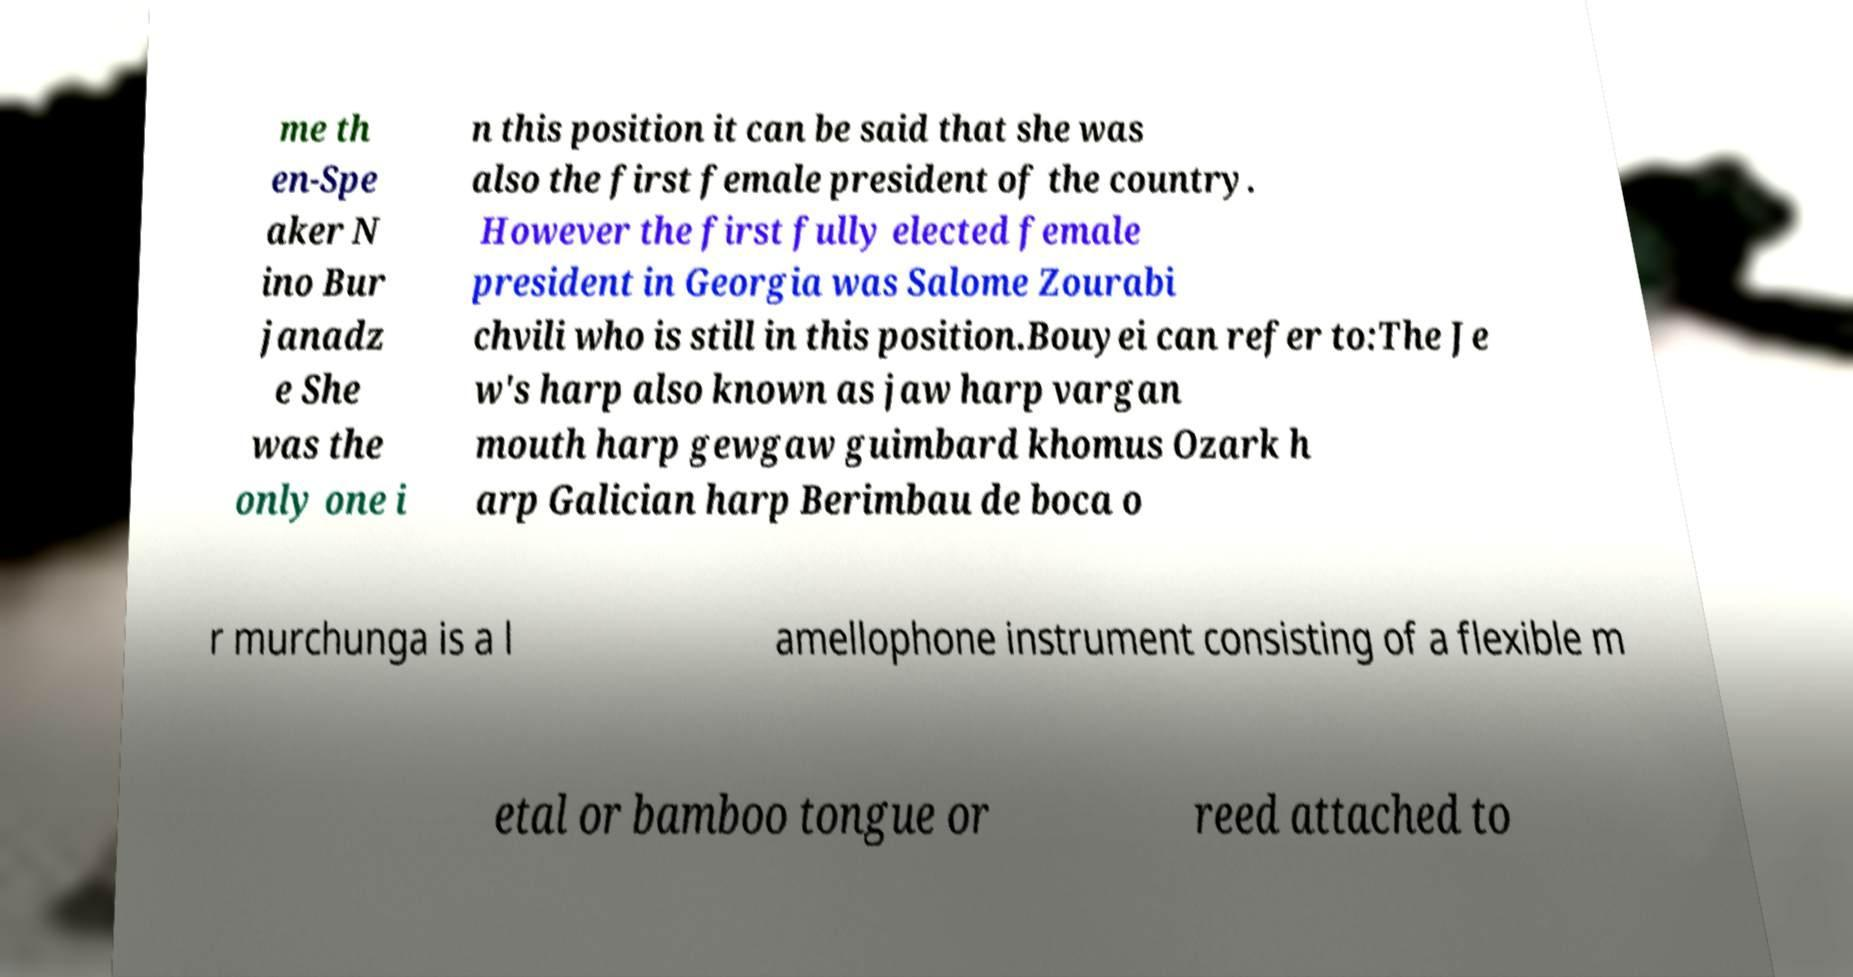What messages or text are displayed in this image? I need them in a readable, typed format. me th en-Spe aker N ino Bur janadz e She was the only one i n this position it can be said that she was also the first female president of the country. However the first fully elected female president in Georgia was Salome Zourabi chvili who is still in this position.Bouyei can refer to:The Je w's harp also known as jaw harp vargan mouth harp gewgaw guimbard khomus Ozark h arp Galician harp Berimbau de boca o r murchunga is a l amellophone instrument consisting of a flexible m etal or bamboo tongue or reed attached to 